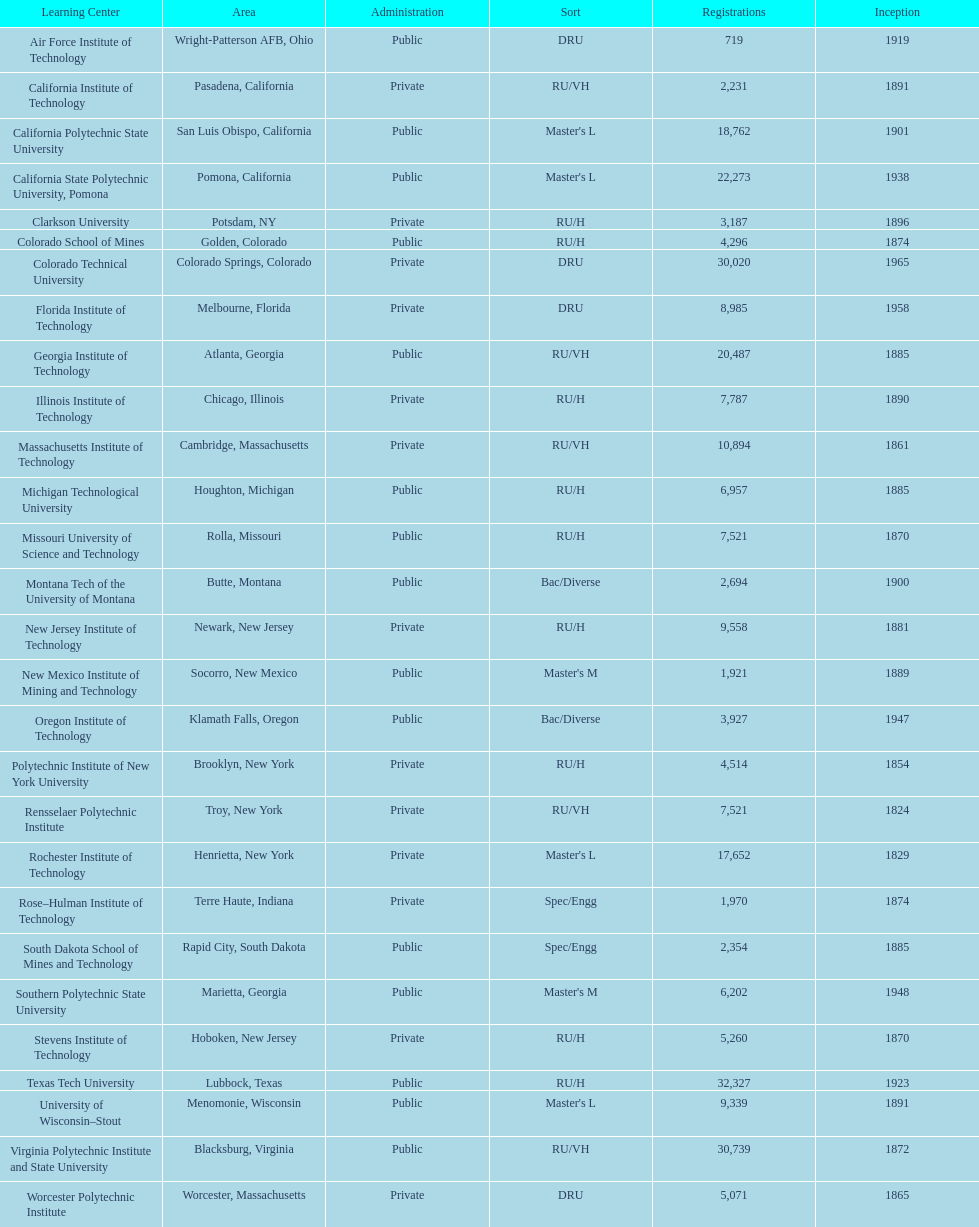Could you parse the entire table? {'header': ['Learning Center', 'Area', 'Administration', 'Sort', 'Registrations', 'Inception'], 'rows': [['Air Force Institute of Technology', 'Wright-Patterson AFB, Ohio', 'Public', 'DRU', '719', '1919'], ['California Institute of Technology', 'Pasadena, California', 'Private', 'RU/VH', '2,231', '1891'], ['California Polytechnic State University', 'San Luis Obispo, California', 'Public', "Master's L", '18,762', '1901'], ['California State Polytechnic University, Pomona', 'Pomona, California', 'Public', "Master's L", '22,273', '1938'], ['Clarkson University', 'Potsdam, NY', 'Private', 'RU/H', '3,187', '1896'], ['Colorado School of Mines', 'Golden, Colorado', 'Public', 'RU/H', '4,296', '1874'], ['Colorado Technical University', 'Colorado Springs, Colorado', 'Private', 'DRU', '30,020', '1965'], ['Florida Institute of Technology', 'Melbourne, Florida', 'Private', 'DRU', '8,985', '1958'], ['Georgia Institute of Technology', 'Atlanta, Georgia', 'Public', 'RU/VH', '20,487', '1885'], ['Illinois Institute of Technology', 'Chicago, Illinois', 'Private', 'RU/H', '7,787', '1890'], ['Massachusetts Institute of Technology', 'Cambridge, Massachusetts', 'Private', 'RU/VH', '10,894', '1861'], ['Michigan Technological University', 'Houghton, Michigan', 'Public', 'RU/H', '6,957', '1885'], ['Missouri University of Science and Technology', 'Rolla, Missouri', 'Public', 'RU/H', '7,521', '1870'], ['Montana Tech of the University of Montana', 'Butte, Montana', 'Public', 'Bac/Diverse', '2,694', '1900'], ['New Jersey Institute of Technology', 'Newark, New Jersey', 'Private', 'RU/H', '9,558', '1881'], ['New Mexico Institute of Mining and Technology', 'Socorro, New Mexico', 'Public', "Master's M", '1,921', '1889'], ['Oregon Institute of Technology', 'Klamath Falls, Oregon', 'Public', 'Bac/Diverse', '3,927', '1947'], ['Polytechnic Institute of New York University', 'Brooklyn, New York', 'Private', 'RU/H', '4,514', '1854'], ['Rensselaer Polytechnic Institute', 'Troy, New York', 'Private', 'RU/VH', '7,521', '1824'], ['Rochester Institute of Technology', 'Henrietta, New York', 'Private', "Master's L", '17,652', '1829'], ['Rose–Hulman Institute of Technology', 'Terre Haute, Indiana', 'Private', 'Spec/Engg', '1,970', '1874'], ['South Dakota School of Mines and Technology', 'Rapid City, South Dakota', 'Public', 'Spec/Engg', '2,354', '1885'], ['Southern Polytechnic State University', 'Marietta, Georgia', 'Public', "Master's M", '6,202', '1948'], ['Stevens Institute of Technology', 'Hoboken, New Jersey', 'Private', 'RU/H', '5,260', '1870'], ['Texas Tech University', 'Lubbock, Texas', 'Public', 'RU/H', '32,327', '1923'], ['University of Wisconsin–Stout', 'Menomonie, Wisconsin', 'Public', "Master's L", '9,339', '1891'], ['Virginia Polytechnic Institute and State University', 'Blacksburg, Virginia', 'Public', 'RU/VH', '30,739', '1872'], ['Worcester Polytechnic Institute', 'Worcester, Massachusetts', 'Private', 'DRU', '5,071', '1865']]} What is the total number of schools listed in the table? 28. 